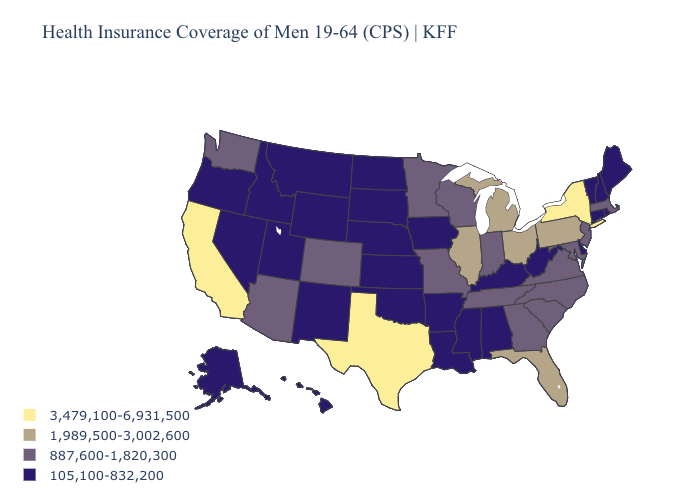Name the states that have a value in the range 3,479,100-6,931,500?
Concise answer only. California, New York, Texas. Name the states that have a value in the range 1,989,500-3,002,600?
Short answer required. Florida, Illinois, Michigan, Ohio, Pennsylvania. Name the states that have a value in the range 3,479,100-6,931,500?
Keep it brief. California, New York, Texas. Is the legend a continuous bar?
Answer briefly. No. How many symbols are there in the legend?
Keep it brief. 4. What is the value of Florida?
Be succinct. 1,989,500-3,002,600. What is the highest value in the USA?
Quick response, please. 3,479,100-6,931,500. Among the states that border New Hampshire , does Massachusetts have the highest value?
Keep it brief. Yes. What is the value of Texas?
Short answer required. 3,479,100-6,931,500. Which states hav the highest value in the South?
Be succinct. Texas. Which states have the lowest value in the Northeast?
Answer briefly. Connecticut, Maine, New Hampshire, Rhode Island, Vermont. Does Washington have the highest value in the West?
Answer briefly. No. Name the states that have a value in the range 105,100-832,200?
Keep it brief. Alabama, Alaska, Arkansas, Connecticut, Delaware, Hawaii, Idaho, Iowa, Kansas, Kentucky, Louisiana, Maine, Mississippi, Montana, Nebraska, Nevada, New Hampshire, New Mexico, North Dakota, Oklahoma, Oregon, Rhode Island, South Dakota, Utah, Vermont, West Virginia, Wyoming. Does West Virginia have the lowest value in the USA?
Quick response, please. Yes. Is the legend a continuous bar?
Answer briefly. No. 